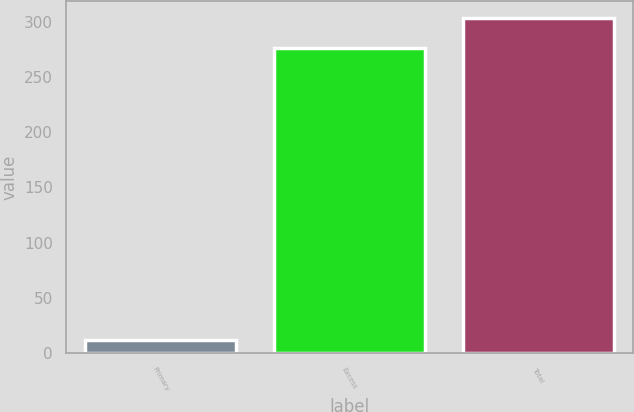<chart> <loc_0><loc_0><loc_500><loc_500><bar_chart><fcel>Primary<fcel>Excess<fcel>Total<nl><fcel>12<fcel>276<fcel>303.6<nl></chart> 